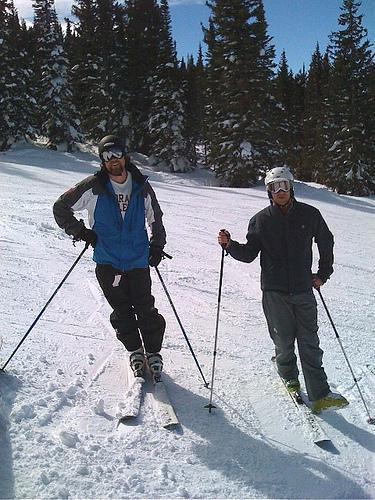How many people are pictured?
Give a very brief answer. 2. 